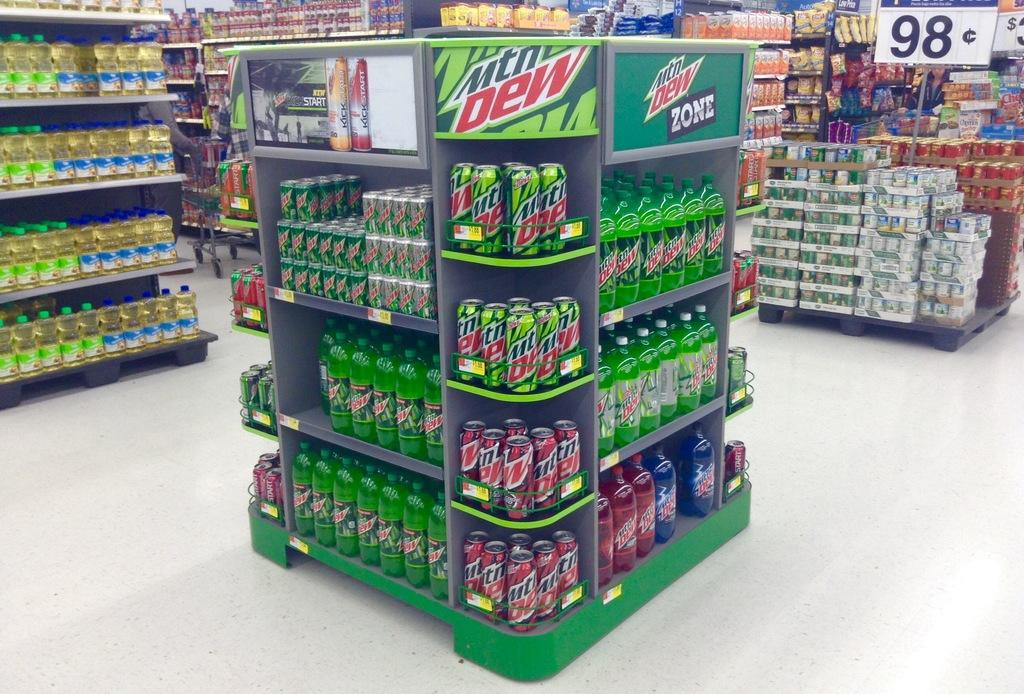<image>
Summarize the visual content of the image. A store has a display of cans that are selling for 98 cents each. 